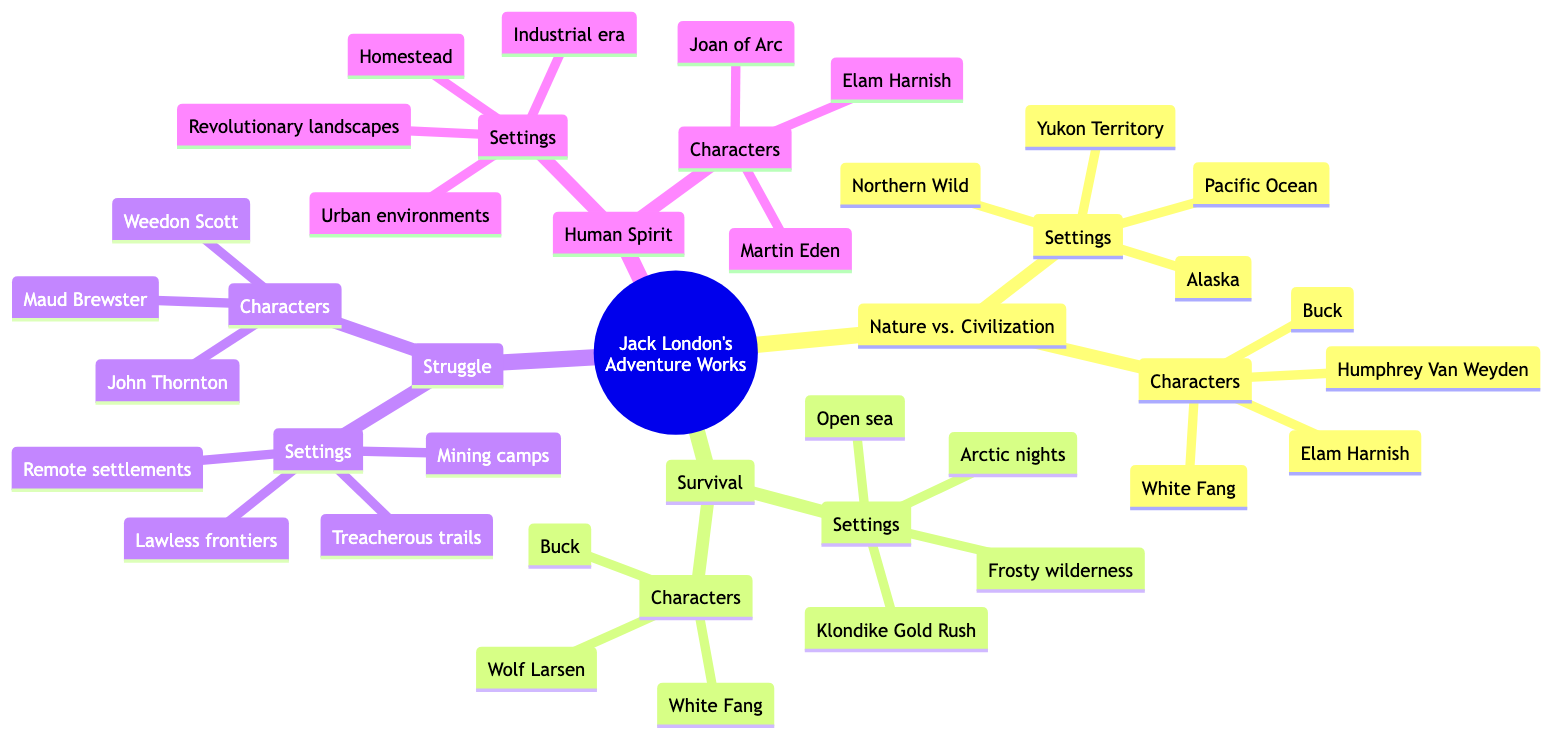What is one character associated with the theme "Nature vs. Civilization"? The diagram lists multiple characters under the "Nature vs. Civilization" theme, including Buck, White Fang, Humphrey Van Weyden, and Elam Harnish. Any of these characters would be an acceptable answer.
Answer: Buck How many themes are presented in the diagram? The diagram contains four main themes: "Nature vs. Civilization," "Survival," "Struggle," and "Human Spirit." Thus, counting these leads directly to the answer.
Answer: 4 What is the setting associated with the theme "Survival"? The "Survival" theme lists several settings including the Klondike Gold Rush, frosty wilderness, open sea, and Arctic nights. Any one of these can answer the question.
Answer: Klondike Gold Rush Which character appears in both the "Nature vs. Civilization" and "Survival" themes? Upon examining the characters listed in both themes, Buck and White Fang are present in both, making them valid answers.
Answer: Buck What is the title of the mind map? The title of the mind map is directly stated at the root of the diagram, which is "Key Themes in Jack London's Adventure Works."
Answer: Key Themes in Jack London's Adventure Works Which setting is associated with the "Human Spirit" theme? Under the "Human Spirit" theme, the settings listed include urban environments, homestead, revolutionary landscapes, and industrial era. Any one of these settings can serve as the answer.
Answer: Urban environments Who is a character associated with the "Struggle" theme? The "Struggle" theme details characters including John Thornton, Weedon Scott, and Maud Brewster. Any of these characters would be correct.
Answer: John Thornton How many settings are listed under the "Survival" theme? The "Survival" theme specifies four particular settings: Klondike Gold Rush, frosty wilderness, open sea, and Arctic nights. Therefore, counting these gives the answer.
Answer: 4 